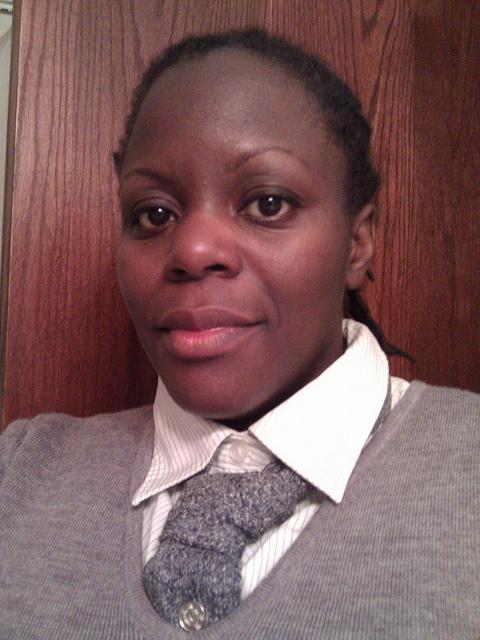What color is the person's shirt?
Short answer required. Gray. What is featured in the background of this image?
Give a very brief answer. Wood. Is she in uniform?
Short answer required. Yes. Is this a man?
Write a very short answer. No. 